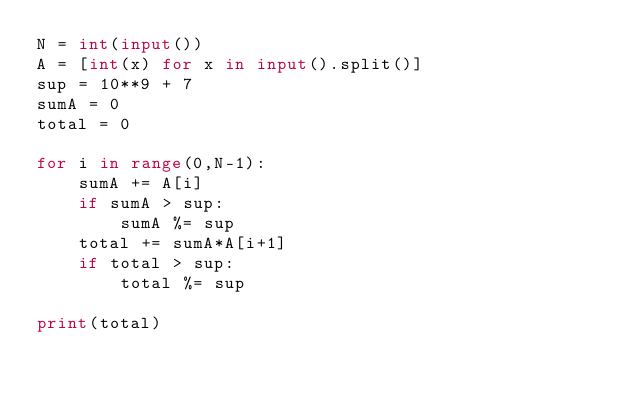Convert code to text. <code><loc_0><loc_0><loc_500><loc_500><_Python_>N = int(input())
A = [int(x) for x in input().split()]
sup = 10**9 + 7 
sumA = 0
total = 0

for i in range(0,N-1):
    sumA += A[i]
    if sumA > sup:
        sumA %= sup
    total += sumA*A[i+1]
    if total > sup:
        total %= sup

print(total)</code> 